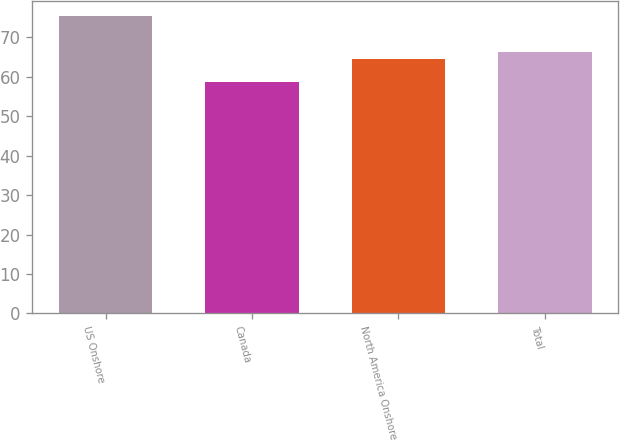<chart> <loc_0><loc_0><loc_500><loc_500><bar_chart><fcel>US Onshore<fcel>Canada<fcel>North America Onshore<fcel>Total<nl><fcel>75.53<fcel>58.6<fcel>64.51<fcel>66.2<nl></chart> 